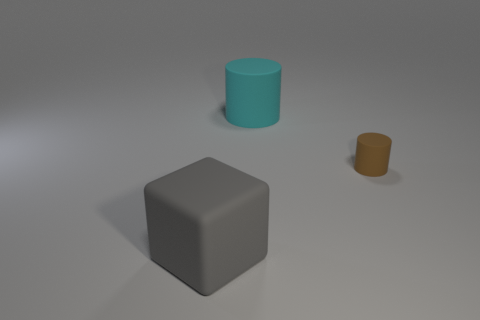Are there any tiny brown rubber things that have the same shape as the cyan rubber thing?
Offer a terse response. Yes. Are the brown object and the thing in front of the brown rubber object made of the same material?
Your answer should be very brief. Yes. What number of other things are there of the same material as the tiny brown cylinder
Provide a succinct answer. 2. Are there more tiny matte things that are left of the rubber block than large blocks?
Provide a succinct answer. No. There is a large matte object that is to the right of the large matte object that is in front of the cyan rubber cylinder; how many large cylinders are behind it?
Your answer should be very brief. 0. Do the large rubber object that is behind the matte block and the brown thing have the same shape?
Ensure brevity in your answer.  Yes. What material is the cylinder that is to the right of the cyan object?
Offer a very short reply. Rubber. What is the shape of the rubber thing that is in front of the cyan matte cylinder and left of the brown rubber cylinder?
Ensure brevity in your answer.  Cube. What is the material of the small brown thing?
Provide a succinct answer. Rubber. What number of cylinders are either tiny brown things or matte objects?
Ensure brevity in your answer.  2. 